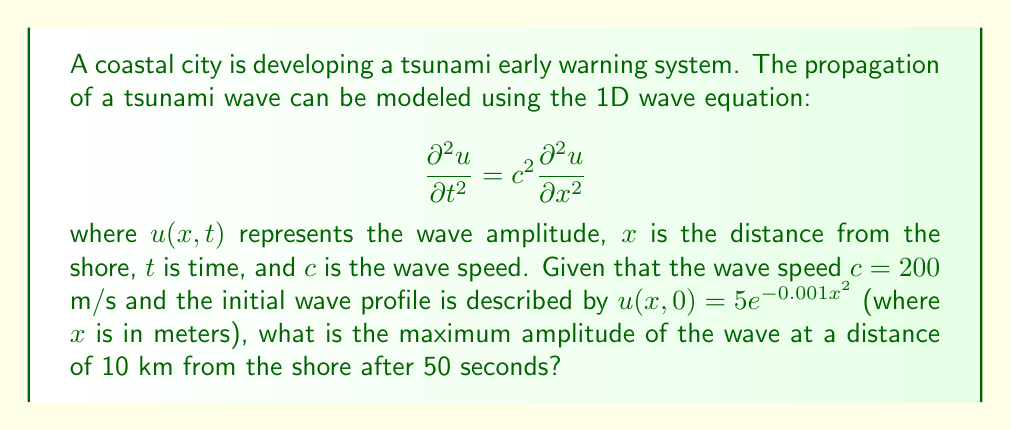What is the answer to this math problem? To solve this problem, we need to use the solution to the 1D wave equation with an initial profile. The general solution is given by D'Alembert's formula:

$$u(x,t) = \frac{1}{2}[f(x+ct) + f(x-ct)]$$

where $f(x)$ is the initial wave profile.

Step 1: Identify the initial wave profile.
$f(x) = 5e^{-0.001x^2}$

Step 2: Substitute the given values into D'Alembert's formula.
$x = 10,000$ m (10 km from shore)
$t = 50$ s
$c = 200$ m/s

$$u(10000,50) = \frac{1}{2}[f(10000+200\cdot50) + f(10000-200\cdot50)]$$
$$= \frac{1}{2}[f(20000) + f(0)]$$

Step 3: Calculate $f(20000)$ and $f(0)$.
$f(20000) = 5e^{-0.001\cdot20000^2} \approx 0$ (negligibly small)
$f(0) = 5e^{-0.001\cdot0^2} = 5$

Step 4: Substitute these values into the equation.
$$u(10000,50) = \frac{1}{2}[0 + 5] = 2.5$$

Therefore, the maximum amplitude of the wave at 10 km from the shore after 50 seconds is 2.5 meters.
Answer: 2.5 meters 